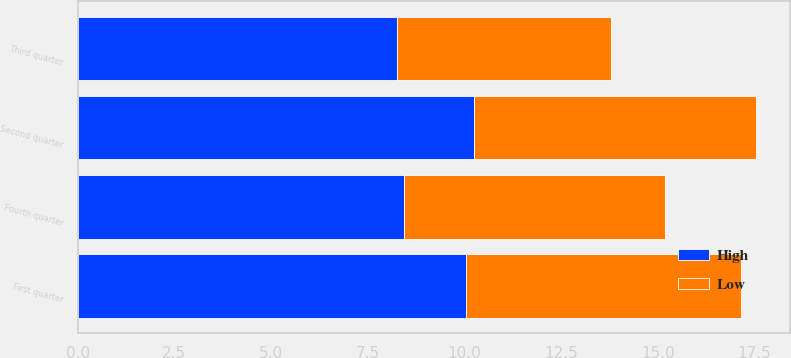Convert chart to OTSL. <chart><loc_0><loc_0><loc_500><loc_500><stacked_bar_chart><ecel><fcel>First quarter<fcel>Second quarter<fcel>Third quarter<fcel>Fourth quarter<nl><fcel>High<fcel>10.04<fcel>10.24<fcel>8.25<fcel>8.43<nl><fcel>Low<fcel>7.1<fcel>7.3<fcel>5.53<fcel>6.77<nl></chart> 